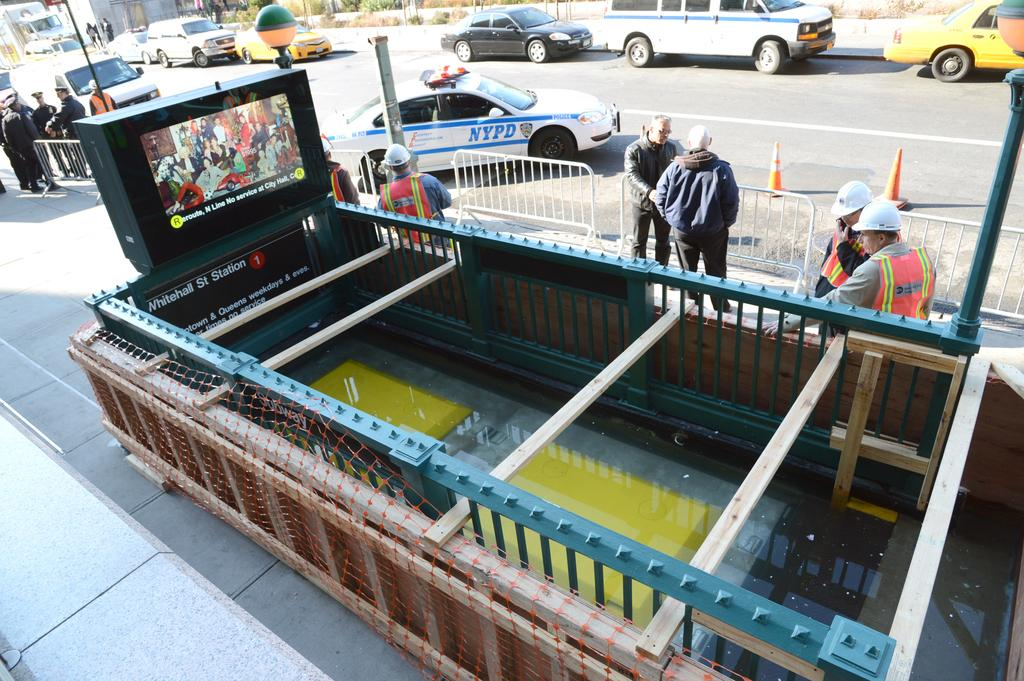Provide a one-sentence caption for the provided image. a group of contraction workers in front of the Whitehall St. Station. 